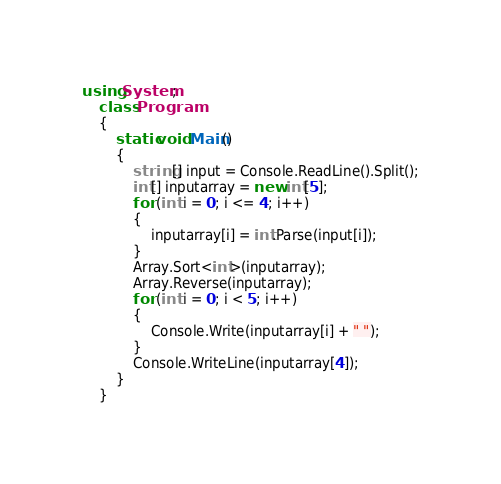Convert code to text. <code><loc_0><loc_0><loc_500><loc_500><_C#_>using System;
    class Program
    {
        static void Main()
        {
            string[] input = Console.ReadLine().Split();
            int[] inputarray = new int[5];
            for (int i = 0; i <= 4; i++)
            {
                inputarray[i] = int.Parse(input[i]);
            }
            Array.Sort<int>(inputarray);
            Array.Reverse(inputarray);
            for (int i = 0; i < 5; i++)
            {
                Console.Write(inputarray[i] + " ");
            }
            Console.WriteLine(inputarray[4]);
        }
    }</code> 